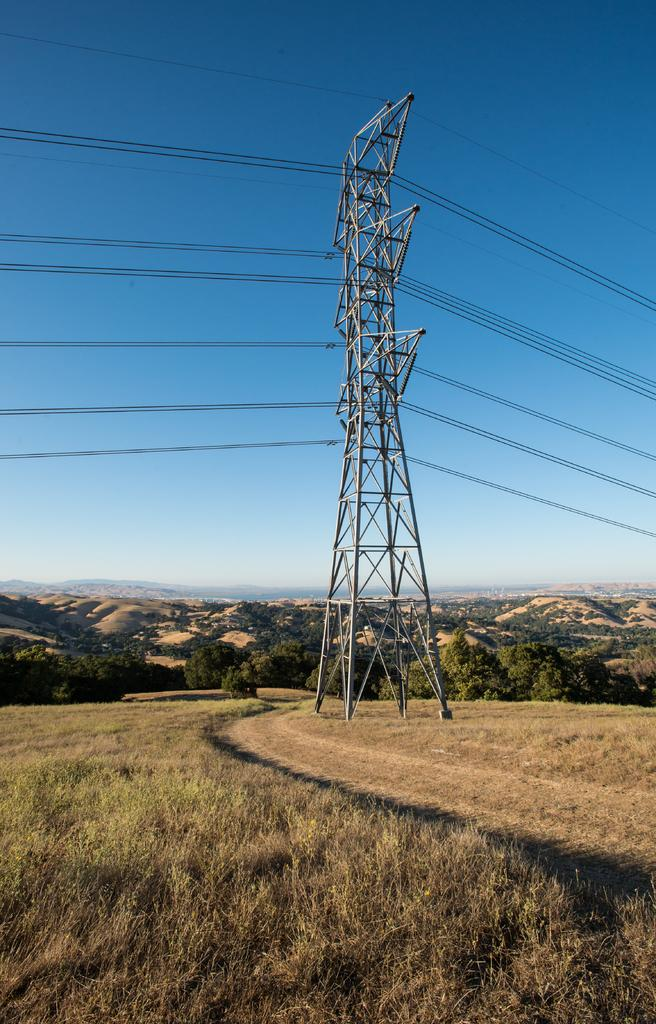What structure is located in the middle of the image? There is a tower in the middle of the image. What type of vegetation is at the bottom of the image? There is grass at the bottom of the image. What can be seen in the background of the image? There are trees in the background of the image. What else is visible in the image besides the tower and grass? There are wires visible in the image. What is visible at the top of the image? The sky is visible at the top of the image. What is your opinion on the sea in the image? There is no sea present in the image, so it is not possible to provide an opinion on it. 